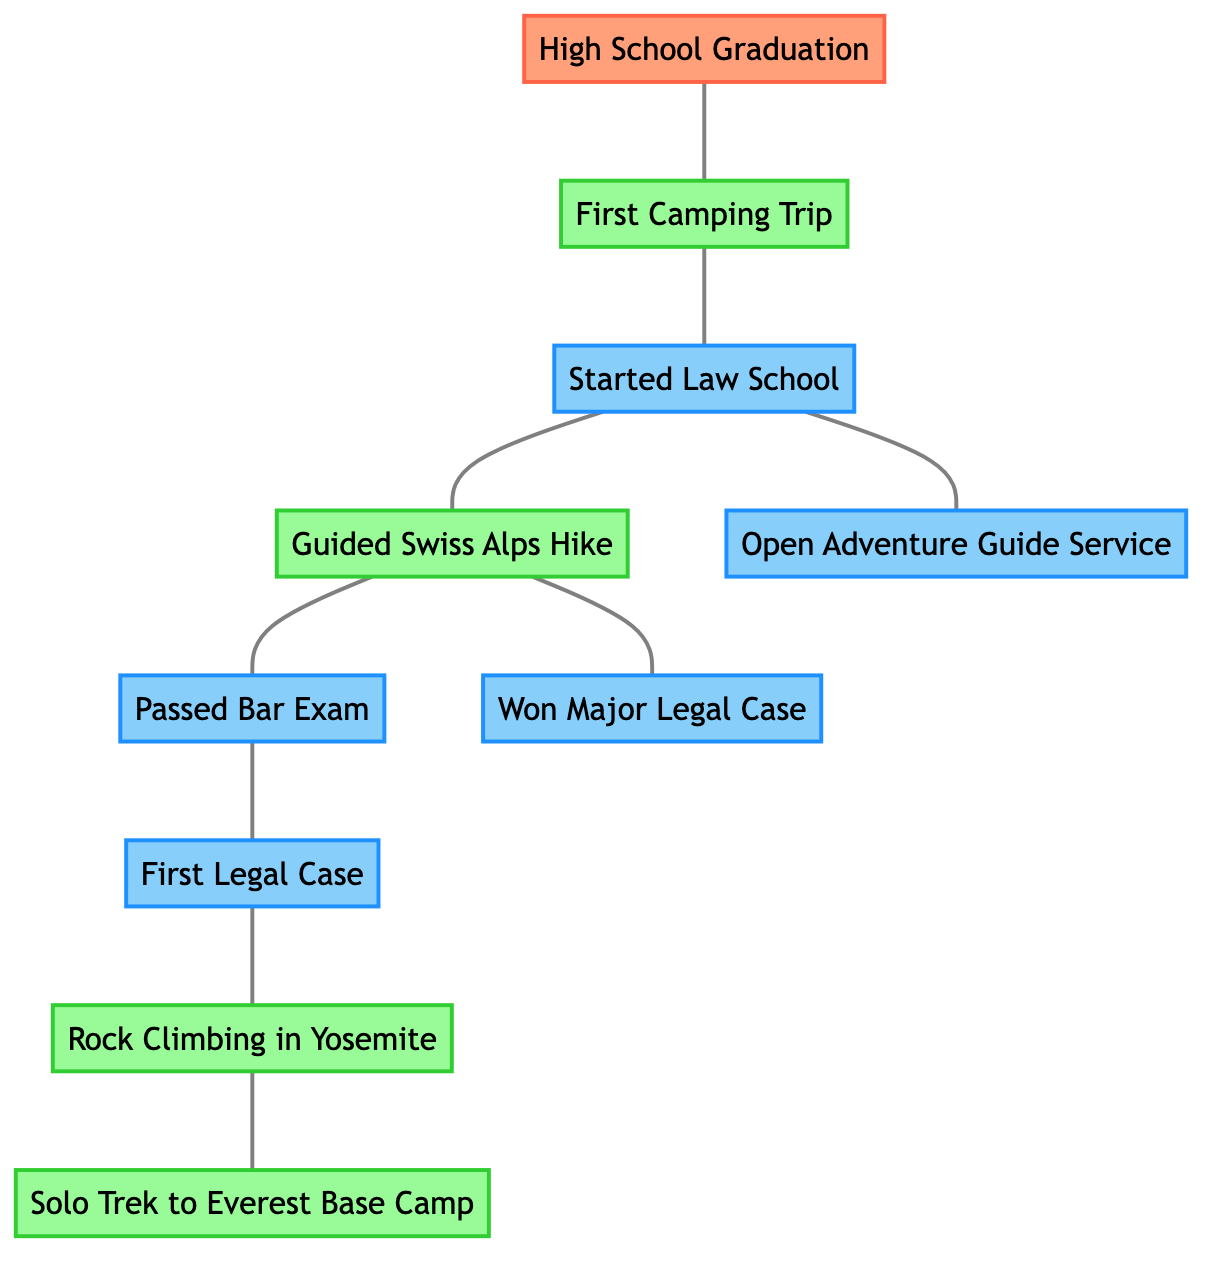What is the first milestone in the timeline? The first milestone in the timeline is "High School Graduation." It is displayed as the first node in the graph and initialized as the entry point of the directed sequence.
Answer: High School Graduation How many adventure nodes are there in the graph? Counting the adventure nodes, we see "First Camping Trip," "Guided Swiss Alps Hike," "Rock Climbing in Yosemite," and "Solo Trek to Everest Base Camp," totaling four nodes categorized as adventures.
Answer: 4 What legal milestone comes after passing the bar exam? Following the node "Passed Bar Exam," we look at the edges emanating from that node, and find the next node is "First Legal Case," which shows the direct relationship and sequential flow in the timeline.
Answer: First Legal Case Identify one adventure that occurs after starting law school. After the node "Started Law School," we check the edges to find both "Guided Swiss Alps Hike" and "Open Adventure Guide Service," which are the adventure nodes directly connected to and occurring later.
Answer: Guided Swiss Alps Hike How are the "First Legal Case" and "Rock Climbing in Yosemite" nodes connected? Analyzing the graph, "First Legal Case" and "Rock Climbing in Yosemite" are connected indirectly through the flow. "First Legal Case" connects through various milestones and ends at "Rock Climbing in Yosemite," suggesting a developed path and timeline through significant events.
Answer: Indirectly connected How many total edges exist between the nodes? By reviewing the edges listed in the diagram, we see that there are ten connections among the nodes, indicating the relationships and transitions highlighted in the graph.
Answer: 10 Which adventure is connected to the passing of the bar exam? The adventure that is connected to the "Passed Bar Exam" is "Rock Climbing in Yosemite" based on the edge connections from "Passed Bar Exam" to "First Legal Case," which further leads to "Rock Climbing in Yosemite."
Answer: Rock Climbing in Yosemite What is the last adventure noted in the timeline? The last adventure noted in the timeline is "Solo Trek to Everest Base Camp," as it is presented as the terminal node linked through the sequence established by the edges leading from "Rock Climbing in Yosemite."
Answer: Solo Trek to Everest Base Camp 